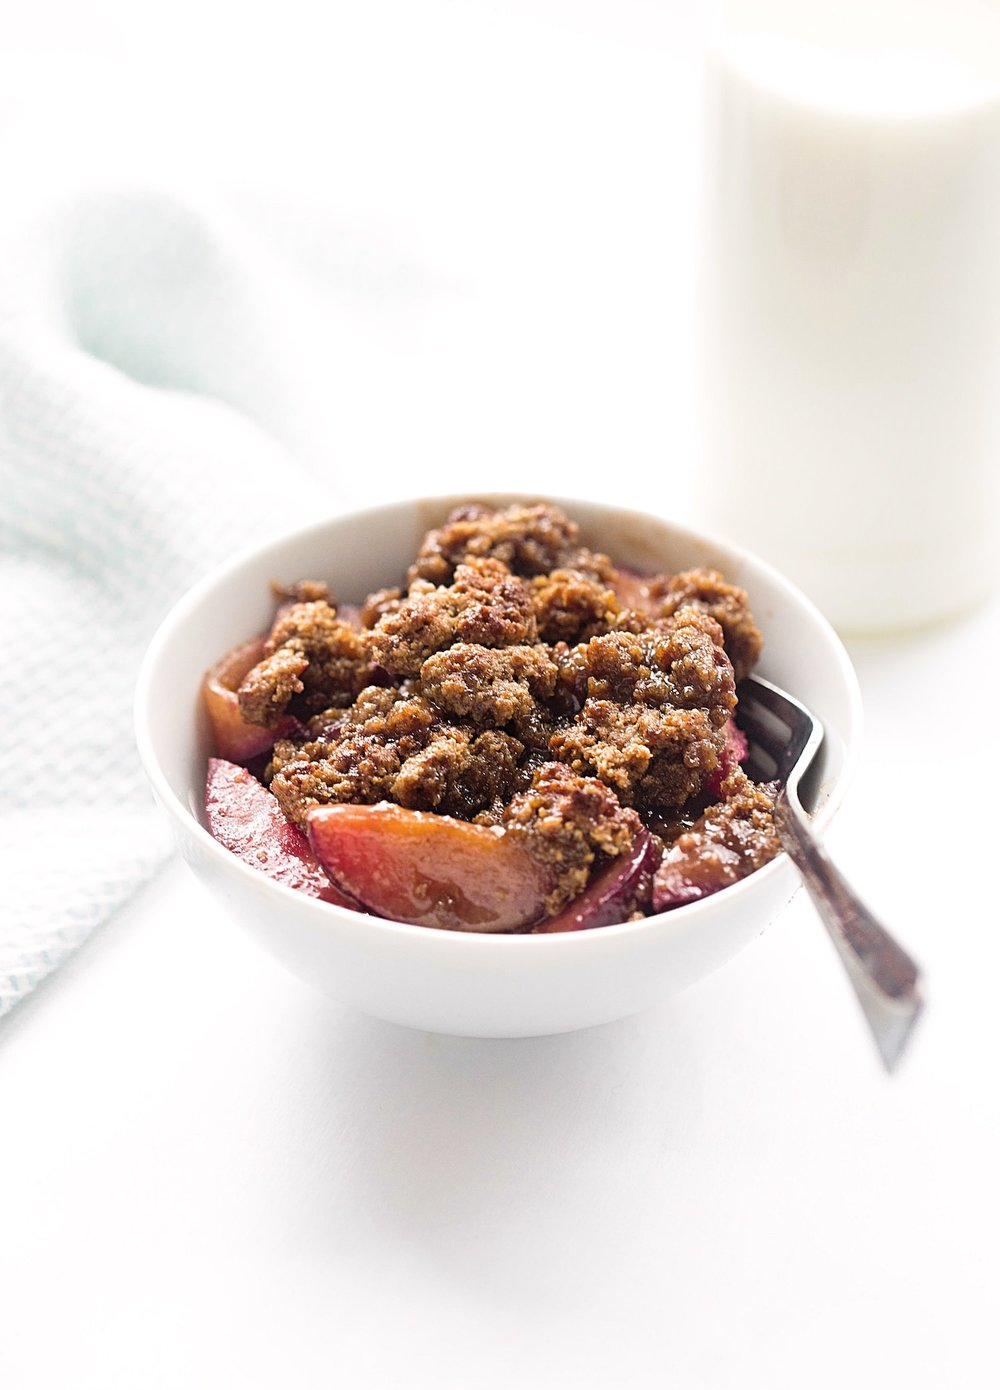Considering the setup of the dessert and the glass of milk, for what type of meal or occasion might this food be typically served? The image shows a tempting fruit crumble, possibly apple or berry, with a golden-brown topping, suggesting a warm, baked dessert. Accompanied by a glass of milk, this inviting combination is often associated with comfort and homeliness, ideal for enjoying as a familial post-dinner treat, a sweet highlight to a weekend brunch, or simply as a delightful afternoon snack. It's a versatile dish that can be scaled up for informal gatherings with friends or family, as well as savored solo for a moment of indulgence. The milk adds a soothing, classic touch, balancing the richness of the dessert, and making the duo a favorite among all ages. 